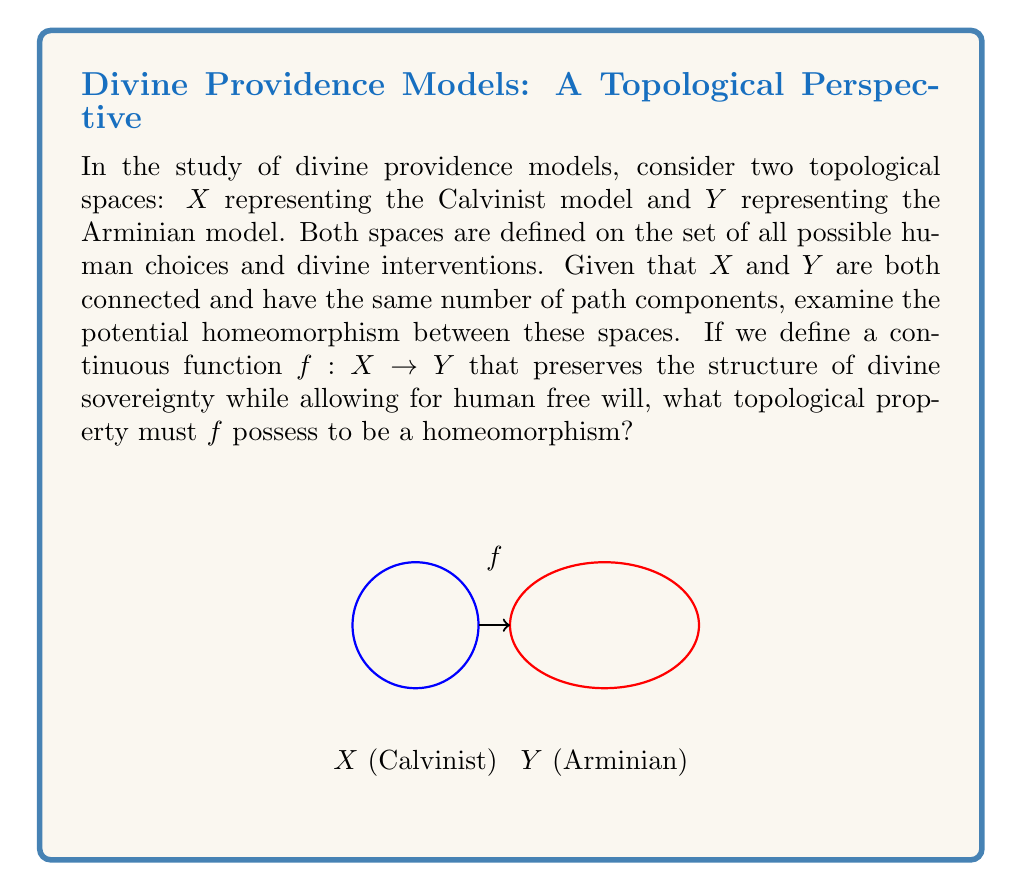Could you help me with this problem? To examine the homeomorphism between the Calvinist model $X$ and the Arminian model $Y$ of divine providence, we need to consider the following steps:

1) First, recall that for $f$ to be a homeomorphism, it must be bijective, continuous, and have a continuous inverse.

2) Given that $X$ and $Y$ are both connected and have the same number of path components, we have a good starting point for a potential homeomorphism.

3) The function $f$ must preserve the topological structure of $X$ while mapping it onto $Y$. This means that the notions of divine sovereignty in the Calvinist model must be continuously transformed into the Arminian model's perspective of free will within God's providential plan.

4) For $f$ to be bijective:
   a) It must be one-to-one (injective): Each point in $X$ must map to a unique point in $Y$.
   b) It must be onto (surjective): Every point in $Y$ must be the image of some point in $X$.

5) The continuity of $f$ ensures that "nearby" points in $X$ (similar providential scenarios) map to "nearby" points in $Y$.

6) For $f$ to have a continuous inverse, it must be an open map. This means that $f$ maps open sets in $X$ to open sets in $Y$.

7) The key topological property that $f$ must possess to be a homeomorphism is that it must be a bijective continuous open map.

8) In the context of divine providence models, this property ensures that the transformation between the Calvinist and Arminian perspectives preserves the fundamental structure of God's sovereignty while allowing for the topological "flexibility" to accommodate different views on human free will.
Answer: $f$ must be a bijective continuous open map. 